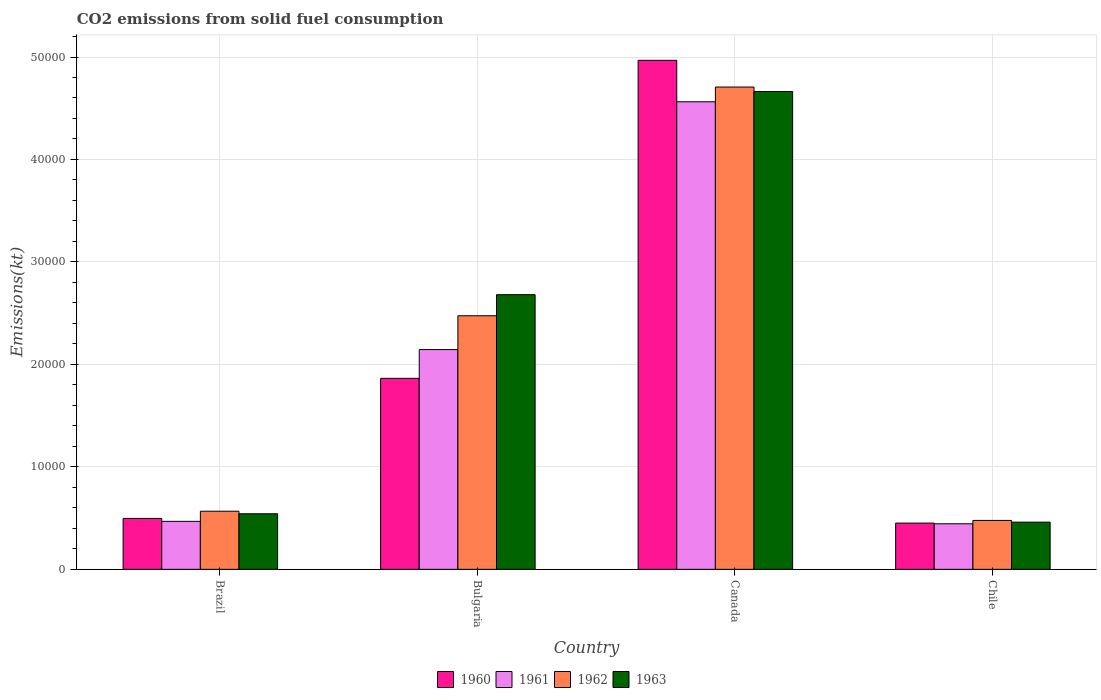How many different coloured bars are there?
Provide a succinct answer. 4. How many groups of bars are there?
Offer a terse response. 4. Are the number of bars per tick equal to the number of legend labels?
Keep it short and to the point. Yes. In how many cases, is the number of bars for a given country not equal to the number of legend labels?
Ensure brevity in your answer.  0. What is the amount of CO2 emitted in 1960 in Bulgaria?
Keep it short and to the point. 1.86e+04. Across all countries, what is the maximum amount of CO2 emitted in 1962?
Provide a succinct answer. 4.71e+04. Across all countries, what is the minimum amount of CO2 emitted in 1963?
Your response must be concise. 4605.75. In which country was the amount of CO2 emitted in 1960 maximum?
Give a very brief answer. Canada. What is the total amount of CO2 emitted in 1962 in the graph?
Make the answer very short. 8.23e+04. What is the difference between the amount of CO2 emitted in 1960 in Brazil and that in Canada?
Your answer should be compact. -4.47e+04. What is the difference between the amount of CO2 emitted in 1960 in Canada and the amount of CO2 emitted in 1962 in Chile?
Your answer should be very brief. 4.49e+04. What is the average amount of CO2 emitted in 1960 per country?
Your answer should be compact. 1.94e+04. What is the difference between the amount of CO2 emitted of/in 1960 and amount of CO2 emitted of/in 1962 in Brazil?
Your response must be concise. -704.06. In how many countries, is the amount of CO2 emitted in 1962 greater than 18000 kt?
Ensure brevity in your answer.  2. What is the ratio of the amount of CO2 emitted in 1963 in Brazil to that in Chile?
Keep it short and to the point. 1.18. What is the difference between the highest and the second highest amount of CO2 emitted in 1960?
Provide a short and direct response. -4.47e+04. What is the difference between the highest and the lowest amount of CO2 emitted in 1962?
Your answer should be very brief. 4.23e+04. In how many countries, is the amount of CO2 emitted in 1963 greater than the average amount of CO2 emitted in 1963 taken over all countries?
Make the answer very short. 2. Is it the case that in every country, the sum of the amount of CO2 emitted in 1961 and amount of CO2 emitted in 1962 is greater than the sum of amount of CO2 emitted in 1960 and amount of CO2 emitted in 1963?
Keep it short and to the point. No. What does the 1st bar from the right in Canada represents?
Your response must be concise. 1963. Is it the case that in every country, the sum of the amount of CO2 emitted in 1962 and amount of CO2 emitted in 1963 is greater than the amount of CO2 emitted in 1961?
Provide a short and direct response. Yes. How many bars are there?
Provide a short and direct response. 16. Are all the bars in the graph horizontal?
Your response must be concise. No. Does the graph contain grids?
Give a very brief answer. Yes. What is the title of the graph?
Make the answer very short. CO2 emissions from solid fuel consumption. Does "1993" appear as one of the legend labels in the graph?
Provide a succinct answer. No. What is the label or title of the X-axis?
Provide a short and direct response. Country. What is the label or title of the Y-axis?
Offer a very short reply. Emissions(kt). What is the Emissions(kt) of 1960 in Brazil?
Your answer should be very brief. 4968.78. What is the Emissions(kt) of 1961 in Brazil?
Give a very brief answer. 4682.76. What is the Emissions(kt) in 1962 in Brazil?
Give a very brief answer. 5672.85. What is the Emissions(kt) of 1963 in Brazil?
Make the answer very short. 5423.49. What is the Emissions(kt) in 1960 in Bulgaria?
Provide a short and direct response. 1.86e+04. What is the Emissions(kt) of 1961 in Bulgaria?
Ensure brevity in your answer.  2.14e+04. What is the Emissions(kt) in 1962 in Bulgaria?
Your answer should be compact. 2.47e+04. What is the Emissions(kt) in 1963 in Bulgaria?
Keep it short and to the point. 2.68e+04. What is the Emissions(kt) of 1960 in Canada?
Offer a very short reply. 4.97e+04. What is the Emissions(kt) of 1961 in Canada?
Provide a succinct answer. 4.56e+04. What is the Emissions(kt) in 1962 in Canada?
Ensure brevity in your answer.  4.71e+04. What is the Emissions(kt) of 1963 in Canada?
Ensure brevity in your answer.  4.66e+04. What is the Emissions(kt) in 1960 in Chile?
Your response must be concise. 4514.08. What is the Emissions(kt) of 1961 in Chile?
Your answer should be very brief. 4444.4. What is the Emissions(kt) in 1962 in Chile?
Your answer should be very brief. 4774.43. What is the Emissions(kt) in 1963 in Chile?
Provide a short and direct response. 4605.75. Across all countries, what is the maximum Emissions(kt) of 1960?
Your answer should be very brief. 4.97e+04. Across all countries, what is the maximum Emissions(kt) of 1961?
Provide a short and direct response. 4.56e+04. Across all countries, what is the maximum Emissions(kt) in 1962?
Give a very brief answer. 4.71e+04. Across all countries, what is the maximum Emissions(kt) in 1963?
Your answer should be very brief. 4.66e+04. Across all countries, what is the minimum Emissions(kt) in 1960?
Offer a terse response. 4514.08. Across all countries, what is the minimum Emissions(kt) in 1961?
Ensure brevity in your answer.  4444.4. Across all countries, what is the minimum Emissions(kt) of 1962?
Make the answer very short. 4774.43. Across all countries, what is the minimum Emissions(kt) of 1963?
Your response must be concise. 4605.75. What is the total Emissions(kt) of 1960 in the graph?
Ensure brevity in your answer.  7.78e+04. What is the total Emissions(kt) in 1961 in the graph?
Make the answer very short. 7.62e+04. What is the total Emissions(kt) of 1962 in the graph?
Your answer should be very brief. 8.23e+04. What is the total Emissions(kt) in 1963 in the graph?
Provide a succinct answer. 8.35e+04. What is the difference between the Emissions(kt) of 1960 in Brazil and that in Bulgaria?
Provide a short and direct response. -1.37e+04. What is the difference between the Emissions(kt) in 1961 in Brazil and that in Bulgaria?
Provide a short and direct response. -1.68e+04. What is the difference between the Emissions(kt) in 1962 in Brazil and that in Bulgaria?
Make the answer very short. -1.91e+04. What is the difference between the Emissions(kt) of 1963 in Brazil and that in Bulgaria?
Your answer should be compact. -2.14e+04. What is the difference between the Emissions(kt) of 1960 in Brazil and that in Canada?
Make the answer very short. -4.47e+04. What is the difference between the Emissions(kt) in 1961 in Brazil and that in Canada?
Your response must be concise. -4.09e+04. What is the difference between the Emissions(kt) in 1962 in Brazil and that in Canada?
Provide a succinct answer. -4.14e+04. What is the difference between the Emissions(kt) in 1963 in Brazil and that in Canada?
Your answer should be very brief. -4.12e+04. What is the difference between the Emissions(kt) of 1960 in Brazil and that in Chile?
Give a very brief answer. 454.71. What is the difference between the Emissions(kt) of 1961 in Brazil and that in Chile?
Offer a terse response. 238.35. What is the difference between the Emissions(kt) in 1962 in Brazil and that in Chile?
Make the answer very short. 898.41. What is the difference between the Emissions(kt) in 1963 in Brazil and that in Chile?
Ensure brevity in your answer.  817.74. What is the difference between the Emissions(kt) in 1960 in Bulgaria and that in Canada?
Provide a succinct answer. -3.10e+04. What is the difference between the Emissions(kt) of 1961 in Bulgaria and that in Canada?
Keep it short and to the point. -2.42e+04. What is the difference between the Emissions(kt) in 1962 in Bulgaria and that in Canada?
Provide a succinct answer. -2.23e+04. What is the difference between the Emissions(kt) in 1963 in Bulgaria and that in Canada?
Provide a succinct answer. -1.98e+04. What is the difference between the Emissions(kt) of 1960 in Bulgaria and that in Chile?
Offer a very short reply. 1.41e+04. What is the difference between the Emissions(kt) of 1961 in Bulgaria and that in Chile?
Provide a short and direct response. 1.70e+04. What is the difference between the Emissions(kt) of 1962 in Bulgaria and that in Chile?
Offer a terse response. 2.00e+04. What is the difference between the Emissions(kt) of 1963 in Bulgaria and that in Chile?
Keep it short and to the point. 2.22e+04. What is the difference between the Emissions(kt) of 1960 in Canada and that in Chile?
Make the answer very short. 4.52e+04. What is the difference between the Emissions(kt) of 1961 in Canada and that in Chile?
Your answer should be very brief. 4.12e+04. What is the difference between the Emissions(kt) of 1962 in Canada and that in Chile?
Provide a short and direct response. 4.23e+04. What is the difference between the Emissions(kt) in 1963 in Canada and that in Chile?
Your response must be concise. 4.20e+04. What is the difference between the Emissions(kt) in 1960 in Brazil and the Emissions(kt) in 1961 in Bulgaria?
Provide a succinct answer. -1.65e+04. What is the difference between the Emissions(kt) in 1960 in Brazil and the Emissions(kt) in 1962 in Bulgaria?
Your response must be concise. -1.98e+04. What is the difference between the Emissions(kt) in 1960 in Brazil and the Emissions(kt) in 1963 in Bulgaria?
Offer a very short reply. -2.18e+04. What is the difference between the Emissions(kt) in 1961 in Brazil and the Emissions(kt) in 1962 in Bulgaria?
Ensure brevity in your answer.  -2.01e+04. What is the difference between the Emissions(kt) in 1961 in Brazil and the Emissions(kt) in 1963 in Bulgaria?
Your answer should be compact. -2.21e+04. What is the difference between the Emissions(kt) of 1962 in Brazil and the Emissions(kt) of 1963 in Bulgaria?
Your response must be concise. -2.11e+04. What is the difference between the Emissions(kt) of 1960 in Brazil and the Emissions(kt) of 1961 in Canada?
Give a very brief answer. -4.07e+04. What is the difference between the Emissions(kt) of 1960 in Brazil and the Emissions(kt) of 1962 in Canada?
Provide a short and direct response. -4.21e+04. What is the difference between the Emissions(kt) in 1960 in Brazil and the Emissions(kt) in 1963 in Canada?
Provide a short and direct response. -4.17e+04. What is the difference between the Emissions(kt) in 1961 in Brazil and the Emissions(kt) in 1962 in Canada?
Your answer should be compact. -4.24e+04. What is the difference between the Emissions(kt) of 1961 in Brazil and the Emissions(kt) of 1963 in Canada?
Offer a terse response. -4.20e+04. What is the difference between the Emissions(kt) of 1962 in Brazil and the Emissions(kt) of 1963 in Canada?
Your answer should be very brief. -4.10e+04. What is the difference between the Emissions(kt) of 1960 in Brazil and the Emissions(kt) of 1961 in Chile?
Give a very brief answer. 524.38. What is the difference between the Emissions(kt) in 1960 in Brazil and the Emissions(kt) in 1962 in Chile?
Ensure brevity in your answer.  194.35. What is the difference between the Emissions(kt) of 1960 in Brazil and the Emissions(kt) of 1963 in Chile?
Make the answer very short. 363.03. What is the difference between the Emissions(kt) in 1961 in Brazil and the Emissions(kt) in 1962 in Chile?
Offer a terse response. -91.67. What is the difference between the Emissions(kt) in 1961 in Brazil and the Emissions(kt) in 1963 in Chile?
Provide a short and direct response. 77.01. What is the difference between the Emissions(kt) of 1962 in Brazil and the Emissions(kt) of 1963 in Chile?
Make the answer very short. 1067.1. What is the difference between the Emissions(kt) of 1960 in Bulgaria and the Emissions(kt) of 1961 in Canada?
Ensure brevity in your answer.  -2.70e+04. What is the difference between the Emissions(kt) in 1960 in Bulgaria and the Emissions(kt) in 1962 in Canada?
Ensure brevity in your answer.  -2.84e+04. What is the difference between the Emissions(kt) of 1960 in Bulgaria and the Emissions(kt) of 1963 in Canada?
Keep it short and to the point. -2.80e+04. What is the difference between the Emissions(kt) in 1961 in Bulgaria and the Emissions(kt) in 1962 in Canada?
Provide a succinct answer. -2.56e+04. What is the difference between the Emissions(kt) of 1961 in Bulgaria and the Emissions(kt) of 1963 in Canada?
Keep it short and to the point. -2.52e+04. What is the difference between the Emissions(kt) of 1962 in Bulgaria and the Emissions(kt) of 1963 in Canada?
Ensure brevity in your answer.  -2.19e+04. What is the difference between the Emissions(kt) of 1960 in Bulgaria and the Emissions(kt) of 1961 in Chile?
Give a very brief answer. 1.42e+04. What is the difference between the Emissions(kt) of 1960 in Bulgaria and the Emissions(kt) of 1962 in Chile?
Ensure brevity in your answer.  1.39e+04. What is the difference between the Emissions(kt) in 1960 in Bulgaria and the Emissions(kt) in 1963 in Chile?
Your answer should be very brief. 1.40e+04. What is the difference between the Emissions(kt) in 1961 in Bulgaria and the Emissions(kt) in 1962 in Chile?
Give a very brief answer. 1.67e+04. What is the difference between the Emissions(kt) of 1961 in Bulgaria and the Emissions(kt) of 1963 in Chile?
Give a very brief answer. 1.68e+04. What is the difference between the Emissions(kt) in 1962 in Bulgaria and the Emissions(kt) in 1963 in Chile?
Keep it short and to the point. 2.01e+04. What is the difference between the Emissions(kt) in 1960 in Canada and the Emissions(kt) in 1961 in Chile?
Your response must be concise. 4.52e+04. What is the difference between the Emissions(kt) in 1960 in Canada and the Emissions(kt) in 1962 in Chile?
Your response must be concise. 4.49e+04. What is the difference between the Emissions(kt) of 1960 in Canada and the Emissions(kt) of 1963 in Chile?
Your answer should be very brief. 4.51e+04. What is the difference between the Emissions(kt) of 1961 in Canada and the Emissions(kt) of 1962 in Chile?
Provide a short and direct response. 4.09e+04. What is the difference between the Emissions(kt) of 1961 in Canada and the Emissions(kt) of 1963 in Chile?
Ensure brevity in your answer.  4.10e+04. What is the difference between the Emissions(kt) of 1962 in Canada and the Emissions(kt) of 1963 in Chile?
Give a very brief answer. 4.25e+04. What is the average Emissions(kt) of 1960 per country?
Your answer should be compact. 1.94e+04. What is the average Emissions(kt) of 1961 per country?
Provide a succinct answer. 1.91e+04. What is the average Emissions(kt) in 1962 per country?
Provide a short and direct response. 2.06e+04. What is the average Emissions(kt) of 1963 per country?
Offer a terse response. 2.09e+04. What is the difference between the Emissions(kt) in 1960 and Emissions(kt) in 1961 in Brazil?
Provide a short and direct response. 286.03. What is the difference between the Emissions(kt) of 1960 and Emissions(kt) of 1962 in Brazil?
Offer a terse response. -704.06. What is the difference between the Emissions(kt) of 1960 and Emissions(kt) of 1963 in Brazil?
Keep it short and to the point. -454.71. What is the difference between the Emissions(kt) in 1961 and Emissions(kt) in 1962 in Brazil?
Make the answer very short. -990.09. What is the difference between the Emissions(kt) in 1961 and Emissions(kt) in 1963 in Brazil?
Provide a short and direct response. -740.73. What is the difference between the Emissions(kt) in 1962 and Emissions(kt) in 1963 in Brazil?
Provide a succinct answer. 249.36. What is the difference between the Emissions(kt) of 1960 and Emissions(kt) of 1961 in Bulgaria?
Give a very brief answer. -2808.92. What is the difference between the Emissions(kt) of 1960 and Emissions(kt) of 1962 in Bulgaria?
Your response must be concise. -6109.22. What is the difference between the Emissions(kt) in 1960 and Emissions(kt) in 1963 in Bulgaria?
Your answer should be very brief. -8166.41. What is the difference between the Emissions(kt) in 1961 and Emissions(kt) in 1962 in Bulgaria?
Make the answer very short. -3300.3. What is the difference between the Emissions(kt) of 1961 and Emissions(kt) of 1963 in Bulgaria?
Keep it short and to the point. -5357.49. What is the difference between the Emissions(kt) in 1962 and Emissions(kt) in 1963 in Bulgaria?
Your answer should be compact. -2057.19. What is the difference between the Emissions(kt) of 1960 and Emissions(kt) of 1961 in Canada?
Offer a terse response. 4044.7. What is the difference between the Emissions(kt) of 1960 and Emissions(kt) of 1962 in Canada?
Provide a short and direct response. 2607.24. What is the difference between the Emissions(kt) of 1960 and Emissions(kt) of 1963 in Canada?
Provide a succinct answer. 3039.94. What is the difference between the Emissions(kt) in 1961 and Emissions(kt) in 1962 in Canada?
Offer a terse response. -1437.46. What is the difference between the Emissions(kt) in 1961 and Emissions(kt) in 1963 in Canada?
Your answer should be compact. -1004.76. What is the difference between the Emissions(kt) of 1962 and Emissions(kt) of 1963 in Canada?
Your answer should be very brief. 432.71. What is the difference between the Emissions(kt) of 1960 and Emissions(kt) of 1961 in Chile?
Provide a succinct answer. 69.67. What is the difference between the Emissions(kt) in 1960 and Emissions(kt) in 1962 in Chile?
Your answer should be very brief. -260.36. What is the difference between the Emissions(kt) of 1960 and Emissions(kt) of 1963 in Chile?
Give a very brief answer. -91.67. What is the difference between the Emissions(kt) of 1961 and Emissions(kt) of 1962 in Chile?
Give a very brief answer. -330.03. What is the difference between the Emissions(kt) in 1961 and Emissions(kt) in 1963 in Chile?
Offer a terse response. -161.35. What is the difference between the Emissions(kt) in 1962 and Emissions(kt) in 1963 in Chile?
Offer a terse response. 168.68. What is the ratio of the Emissions(kt) of 1960 in Brazil to that in Bulgaria?
Make the answer very short. 0.27. What is the ratio of the Emissions(kt) in 1961 in Brazil to that in Bulgaria?
Offer a very short reply. 0.22. What is the ratio of the Emissions(kt) of 1962 in Brazil to that in Bulgaria?
Give a very brief answer. 0.23. What is the ratio of the Emissions(kt) of 1963 in Brazil to that in Bulgaria?
Your response must be concise. 0.2. What is the ratio of the Emissions(kt) in 1961 in Brazil to that in Canada?
Your response must be concise. 0.1. What is the ratio of the Emissions(kt) in 1962 in Brazil to that in Canada?
Your answer should be very brief. 0.12. What is the ratio of the Emissions(kt) of 1963 in Brazil to that in Canada?
Your answer should be very brief. 0.12. What is the ratio of the Emissions(kt) in 1960 in Brazil to that in Chile?
Your answer should be very brief. 1.1. What is the ratio of the Emissions(kt) of 1961 in Brazil to that in Chile?
Give a very brief answer. 1.05. What is the ratio of the Emissions(kt) in 1962 in Brazil to that in Chile?
Offer a terse response. 1.19. What is the ratio of the Emissions(kt) of 1963 in Brazil to that in Chile?
Your answer should be compact. 1.18. What is the ratio of the Emissions(kt) in 1960 in Bulgaria to that in Canada?
Your answer should be very brief. 0.38. What is the ratio of the Emissions(kt) in 1961 in Bulgaria to that in Canada?
Provide a short and direct response. 0.47. What is the ratio of the Emissions(kt) in 1962 in Bulgaria to that in Canada?
Ensure brevity in your answer.  0.53. What is the ratio of the Emissions(kt) in 1963 in Bulgaria to that in Canada?
Give a very brief answer. 0.57. What is the ratio of the Emissions(kt) of 1960 in Bulgaria to that in Chile?
Ensure brevity in your answer.  4.13. What is the ratio of the Emissions(kt) in 1961 in Bulgaria to that in Chile?
Keep it short and to the point. 4.83. What is the ratio of the Emissions(kt) in 1962 in Bulgaria to that in Chile?
Keep it short and to the point. 5.18. What is the ratio of the Emissions(kt) of 1963 in Bulgaria to that in Chile?
Provide a succinct answer. 5.82. What is the ratio of the Emissions(kt) in 1960 in Canada to that in Chile?
Your answer should be very brief. 11. What is the ratio of the Emissions(kt) of 1961 in Canada to that in Chile?
Your answer should be compact. 10.27. What is the ratio of the Emissions(kt) in 1962 in Canada to that in Chile?
Ensure brevity in your answer.  9.86. What is the ratio of the Emissions(kt) of 1963 in Canada to that in Chile?
Offer a terse response. 10.13. What is the difference between the highest and the second highest Emissions(kt) in 1960?
Provide a short and direct response. 3.10e+04. What is the difference between the highest and the second highest Emissions(kt) of 1961?
Make the answer very short. 2.42e+04. What is the difference between the highest and the second highest Emissions(kt) in 1962?
Your response must be concise. 2.23e+04. What is the difference between the highest and the second highest Emissions(kt) of 1963?
Provide a short and direct response. 1.98e+04. What is the difference between the highest and the lowest Emissions(kt) of 1960?
Provide a short and direct response. 4.52e+04. What is the difference between the highest and the lowest Emissions(kt) of 1961?
Keep it short and to the point. 4.12e+04. What is the difference between the highest and the lowest Emissions(kt) in 1962?
Your answer should be compact. 4.23e+04. What is the difference between the highest and the lowest Emissions(kt) of 1963?
Provide a short and direct response. 4.20e+04. 